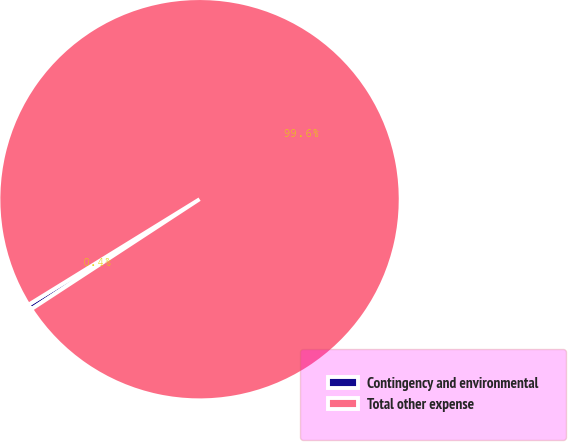<chart> <loc_0><loc_0><loc_500><loc_500><pie_chart><fcel>Contingency and environmental<fcel>Total other expense<nl><fcel>0.42%<fcel>99.58%<nl></chart> 